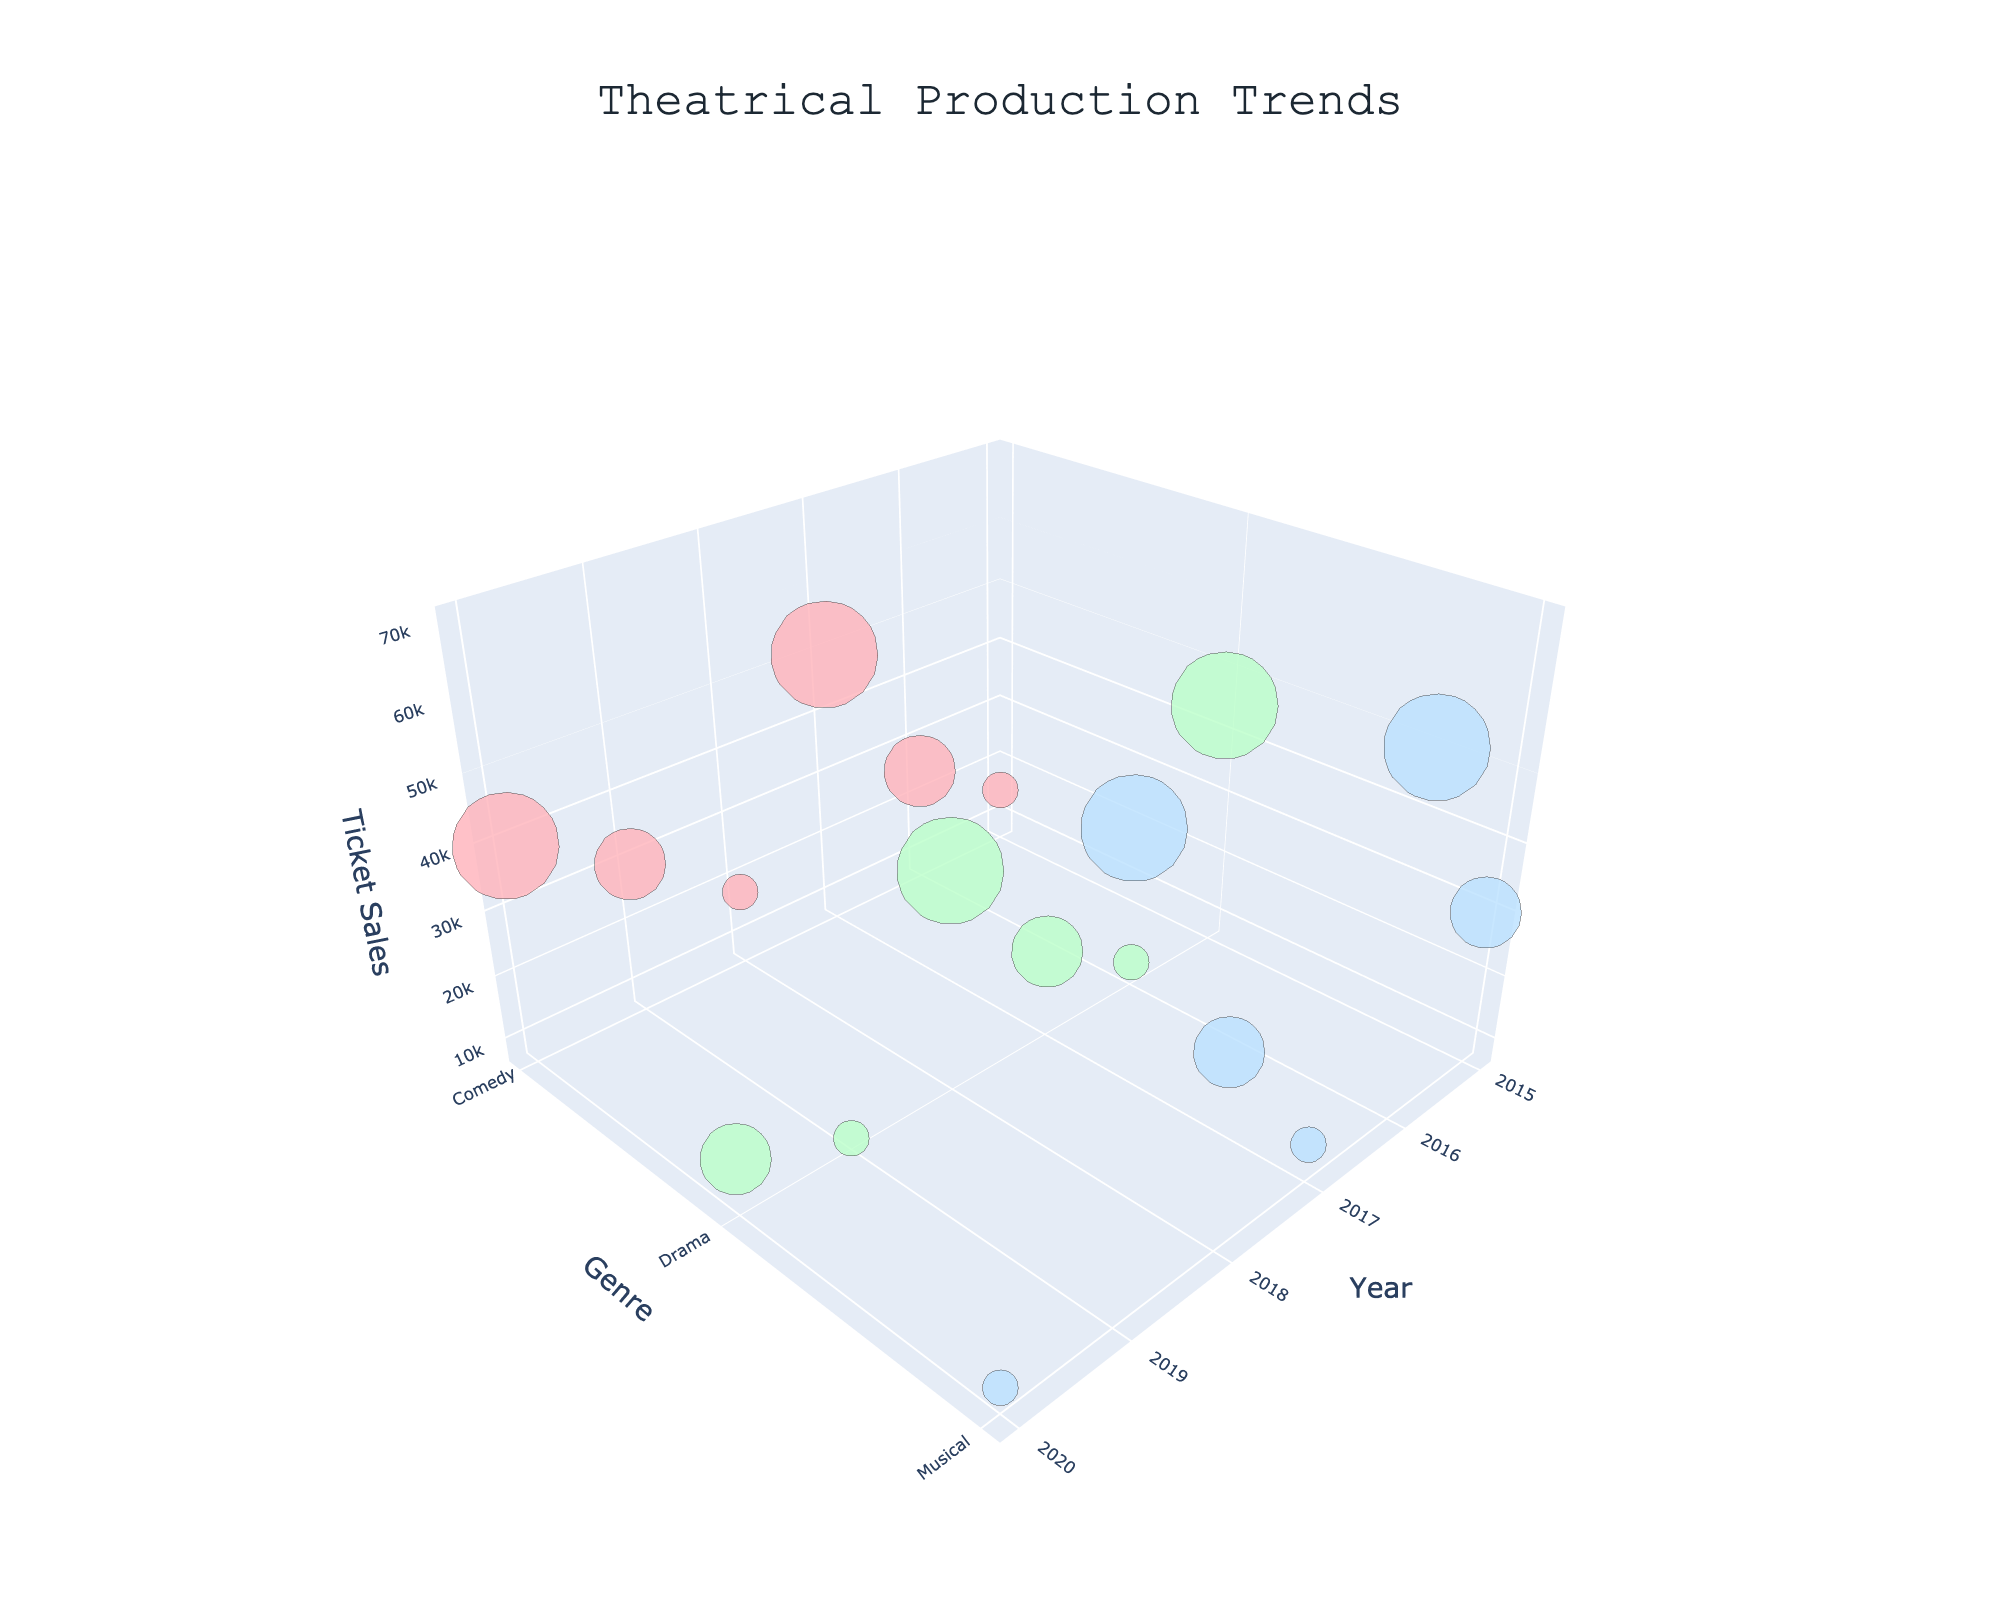How many productions are shown in the figure? Count the number of markers displayed in the 3D bubble chart to find the total number of productions.
Answer: 16 Which genre has the largest venue size in 2019? Check the size of the markers in 2019 and identify the genre of the largest one.
Answer: Musical What’s the difference in ticket sales between the Comedy and Drama productions in 2020? Find the ticket sales values for Comedy and Drama in 2020, then subtract the Drama value from the Comedy value (40000 - 15000).
Answer: 25000 Which genre had the highest ticket sales overall? Look at the highest point on the z-axis (Ticket Sales) and identify its genre.
Answer: Musical In which year did the Comedy genre see the highest ticket sales? Locate the tallest marker for Comedy and note its year from the x-axis.
Answer: 2017 What is the average ticket sales for Musical productions in Medium venues? Sum the ticket sales for Musical productions in Medium venues across all years, and then divide by the number of these productions (30000 + 35000) / 2.
Answer: 32500 Which production had the lowest ticket sales in a Large venue? Identify the smallest marker in the Large venue category and find its production name from the hover info.
Answer: Blithe Spirit Are there more productions in Small or Large venues? Compare the total number of markers representing Small and Large venues.
Answer: Small Which production had the most significant increase in ticket sales from one year to the next? Identify and compare markers to find the greatest increase in ticket sales from one year to the next.
Answer: Hamilton from 2018 to 2019 What’s the total ticket sales for Drama productions in Large venues from 2015 to 2020? Sum the ticket sales for all Drama productions in Large venues over the years (45000 + 40000).
Answer: 85000 